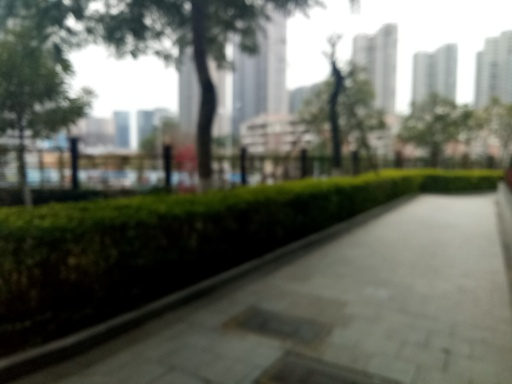Is the overall clarity of the image high? No, the overall clarity of the image is not high. The photo appears to be blurry, making it challenging to discern the finer details of the surroundings such as the textures of the pathway, the shapes of the foliage, and the features of the distant structures. 